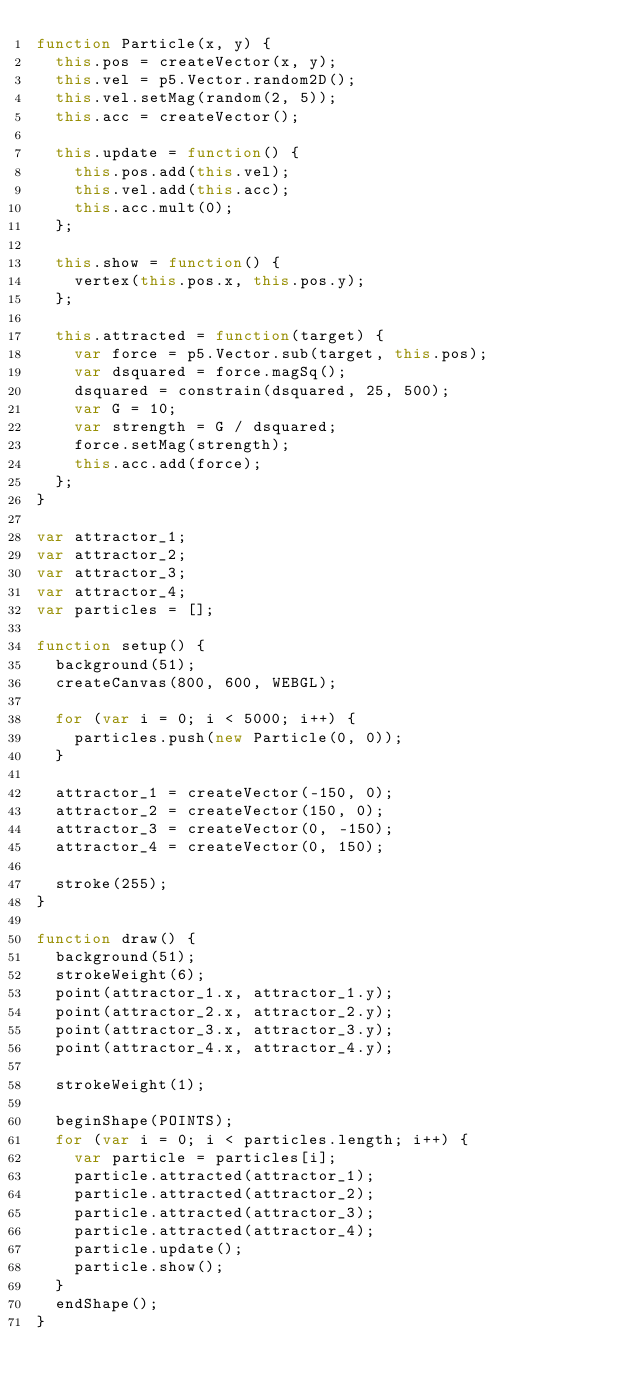Convert code to text. <code><loc_0><loc_0><loc_500><loc_500><_JavaScript_>function Particle(x, y) {
  this.pos = createVector(x, y);
  this.vel = p5.Vector.random2D();
  this.vel.setMag(random(2, 5));
  this.acc = createVector();

  this.update = function() {
    this.pos.add(this.vel);
    this.vel.add(this.acc);
    this.acc.mult(0);
  };

  this.show = function() {
    vertex(this.pos.x, this.pos.y);
  };

  this.attracted = function(target) {
    var force = p5.Vector.sub(target, this.pos);
    var dsquared = force.magSq();
    dsquared = constrain(dsquared, 25, 500);
    var G = 10;
    var strength = G / dsquared;
    force.setMag(strength);
    this.acc.add(force);
  };
}

var attractor_1;
var attractor_2;
var attractor_3;
var attractor_4;
var particles = [];

function setup() {
  background(51);
  createCanvas(800, 600, WEBGL);

  for (var i = 0; i < 5000; i++) {
    particles.push(new Particle(0, 0));
  }

  attractor_1 = createVector(-150, 0);
  attractor_2 = createVector(150, 0);
  attractor_3 = createVector(0, -150);
  attractor_4 = createVector(0, 150);

  stroke(255);
}

function draw() {
  background(51);
  strokeWeight(6);
  point(attractor_1.x, attractor_1.y);
  point(attractor_2.x, attractor_2.y);
  point(attractor_3.x, attractor_3.y);
  point(attractor_4.x, attractor_4.y);

  strokeWeight(1);

  beginShape(POINTS);
  for (var i = 0; i < particles.length; i++) {
    var particle = particles[i];
    particle.attracted(attractor_1);
    particle.attracted(attractor_2);
    particle.attracted(attractor_3);
    particle.attracted(attractor_4);
    particle.update();
    particle.show();
  }
  endShape();
}
</code> 